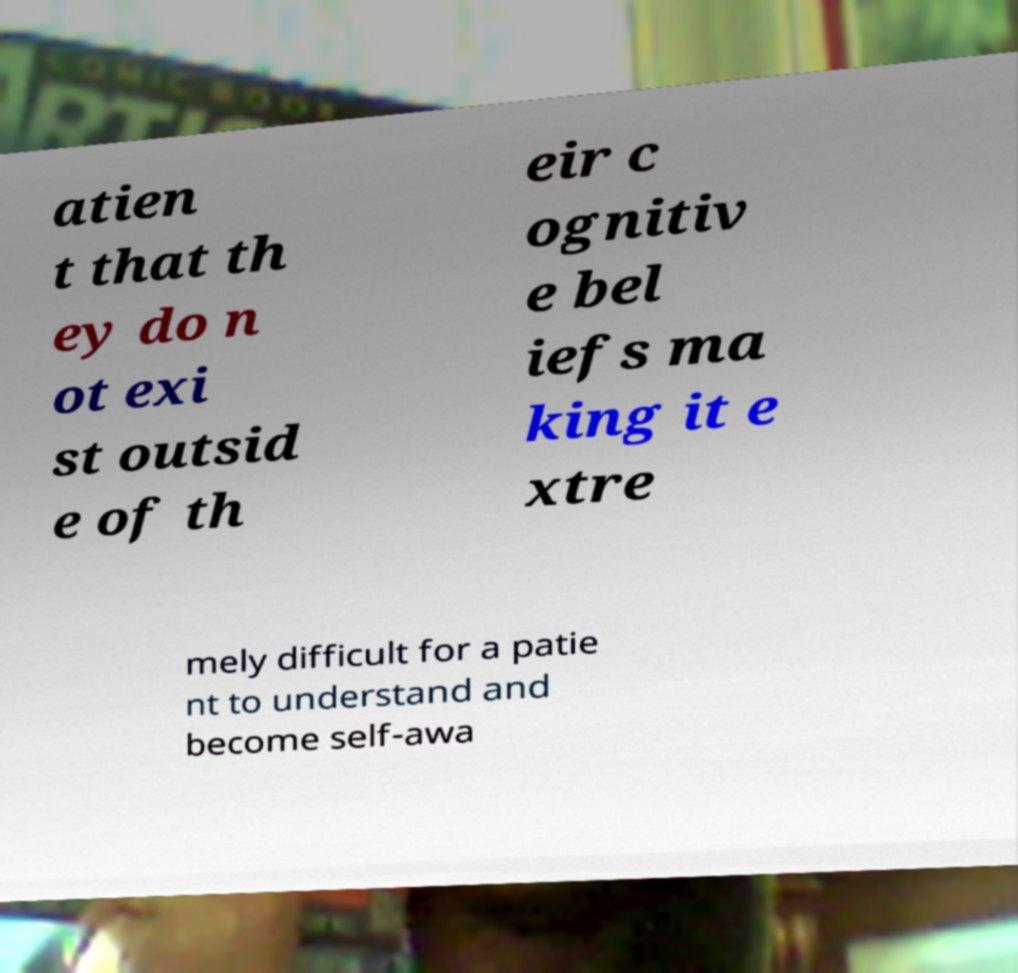For documentation purposes, I need the text within this image transcribed. Could you provide that? atien t that th ey do n ot exi st outsid e of th eir c ognitiv e bel iefs ma king it e xtre mely difficult for a patie nt to understand and become self-awa 